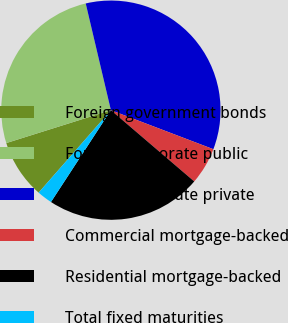<chart> <loc_0><loc_0><loc_500><loc_500><pie_chart><fcel>Foreign government bonds<fcel>Foreign corporate public<fcel>Foreign corporate private<fcel>Commercial mortgage-backed<fcel>Residential mortgage-backed<fcel>Total fixed maturities<nl><fcel>8.7%<fcel>26.16%<fcel>34.48%<fcel>5.47%<fcel>22.94%<fcel>2.25%<nl></chart> 